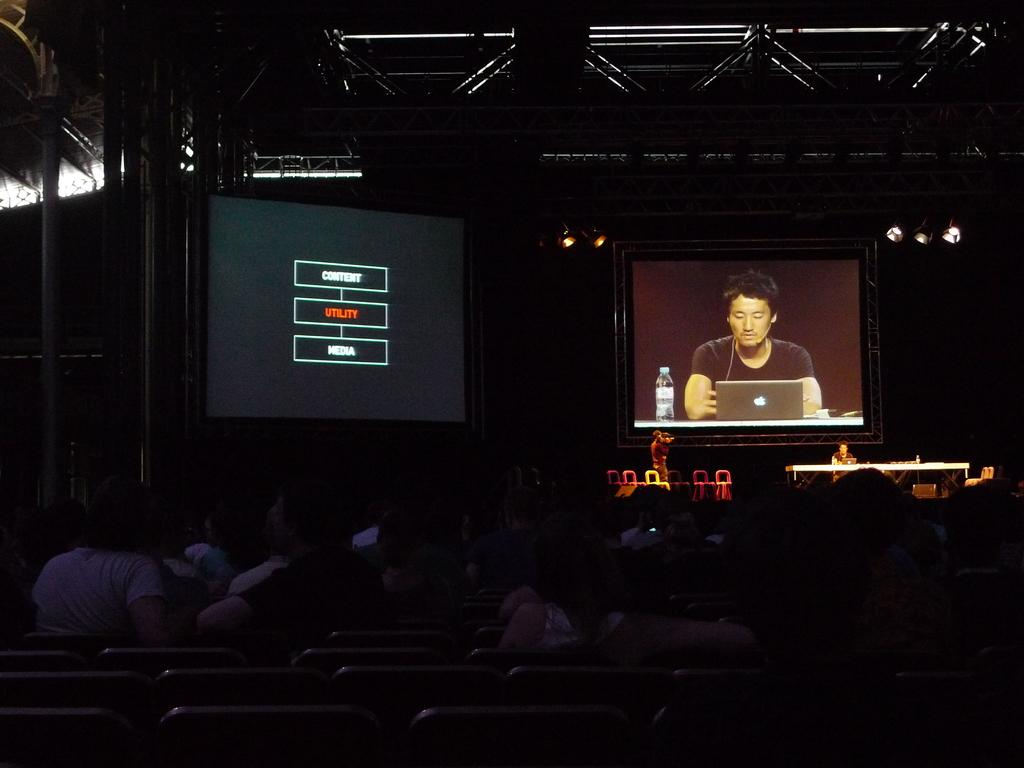What are the people in the image doing at the bottom of the image? There are people sitting at the bottom of the image. What is happening in the middle of the image? There are people on a stage in the middle of the image. What can be seen in the background of the image? There are two screens visible in the background of the image. What type of substance is being used by the people on the stage to create a smile? There are no people on the stage using any substance to create a smile, as the image does not depict such an activity. 